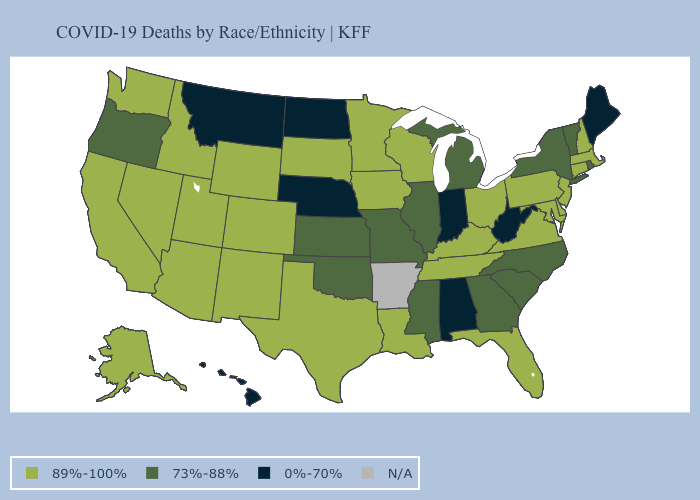What is the value of New Mexico?
Write a very short answer. 89%-100%. Name the states that have a value in the range 0%-70%?
Give a very brief answer. Alabama, Hawaii, Indiana, Maine, Montana, Nebraska, North Dakota, West Virginia. What is the lowest value in states that border South Carolina?
Answer briefly. 73%-88%. Is the legend a continuous bar?
Write a very short answer. No. What is the highest value in the Northeast ?
Keep it brief. 89%-100%. Name the states that have a value in the range 73%-88%?
Short answer required. Georgia, Illinois, Kansas, Michigan, Mississippi, Missouri, New York, North Carolina, Oklahoma, Oregon, Rhode Island, South Carolina, Vermont. What is the value of South Carolina?
Give a very brief answer. 73%-88%. Among the states that border Pennsylvania , does West Virginia have the highest value?
Give a very brief answer. No. What is the lowest value in the USA?
Write a very short answer. 0%-70%. What is the value of Connecticut?
Be succinct. 89%-100%. Does the first symbol in the legend represent the smallest category?
Concise answer only. No. What is the value of Missouri?
Give a very brief answer. 73%-88%. What is the value of Montana?
Quick response, please. 0%-70%. Name the states that have a value in the range N/A?
Keep it brief. Arkansas. What is the highest value in the USA?
Concise answer only. 89%-100%. 